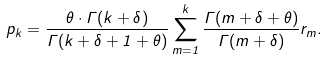Convert formula to latex. <formula><loc_0><loc_0><loc_500><loc_500>p _ { k } = \frac { \theta \cdot \Gamma ( k + \delta ) } { \Gamma ( k + \delta + 1 + \theta ) } \sum _ { m = 1 } ^ { k } \frac { \Gamma ( m + \delta + \theta ) } { \Gamma ( m + \delta ) } r _ { m } .</formula> 